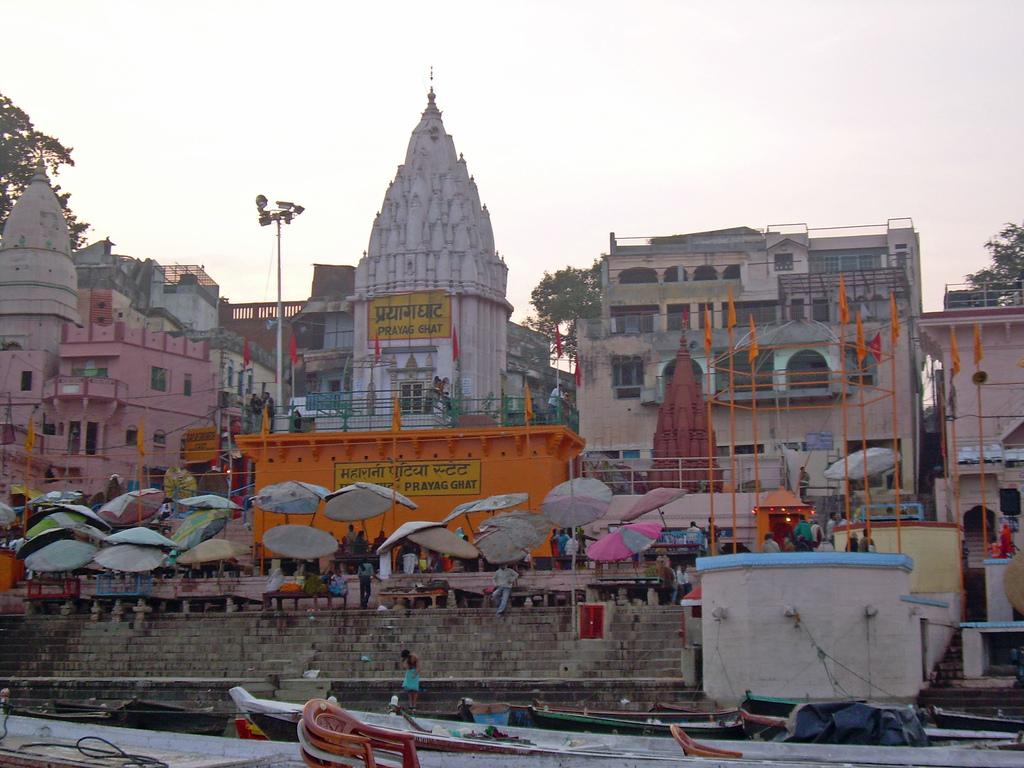What type of vehicles can be seen at the bottom of the image? There are boats at the bottom of the image. What objects are located in the middle of the image? There are umbrellas in the middle of the image. What structures can be seen in the background of the image? There are buildings in the background of the image. What type of vegetation is visible in the background of the image? There are trees in the background of the image. What is visible at the top of the image? The sky is visible at the top of the image. What time does the clock show in the image? There is no clock present in the image. How does the theory of relativity apply to the care of the trees in the background? The theory of relativity is not relevant to the care of the trees in the background, as it is a scientific concept unrelated to the image. 